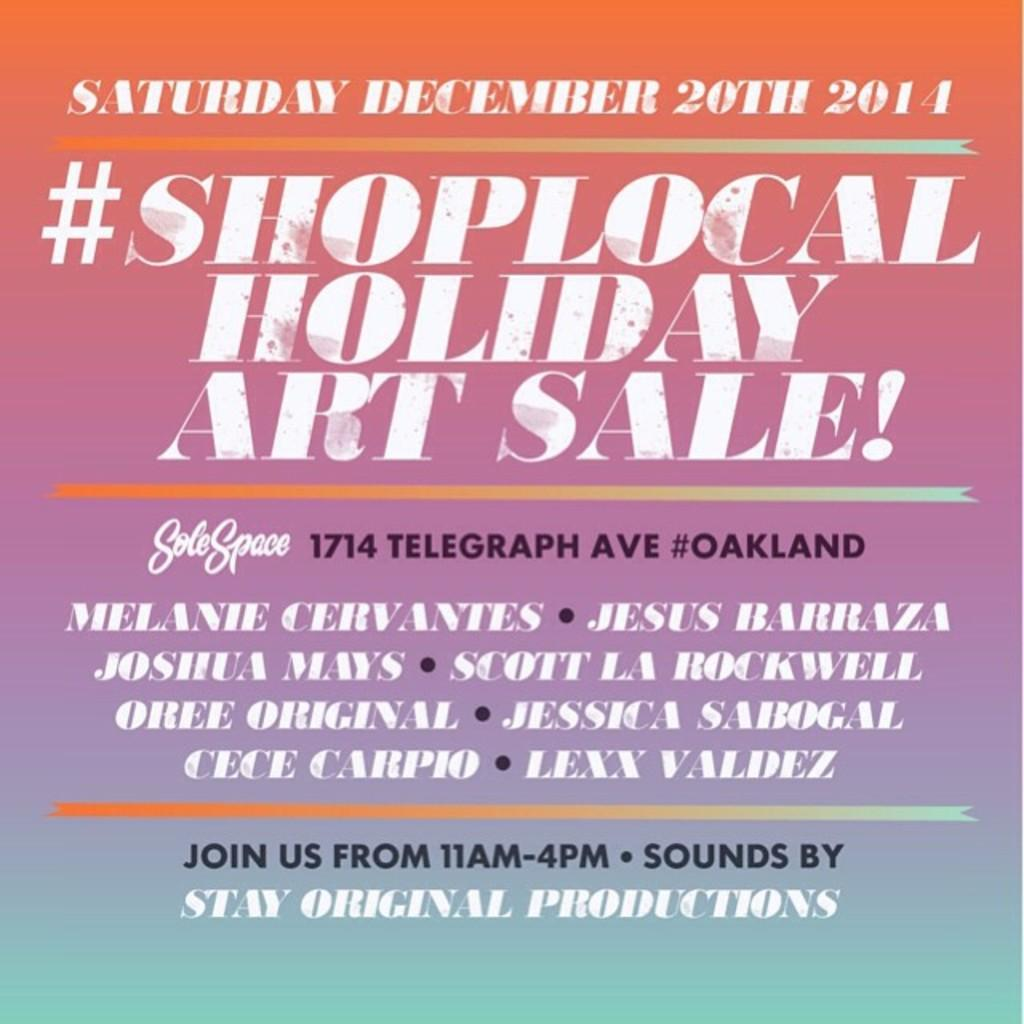What is the main subject of the image? There is an advertisement in the image. What can be found within the advertisement? The advertisement contains text. What type of winter clothing is being advertised in the image? There is no winter clothing present in the image; it only contains an advertisement with text. 